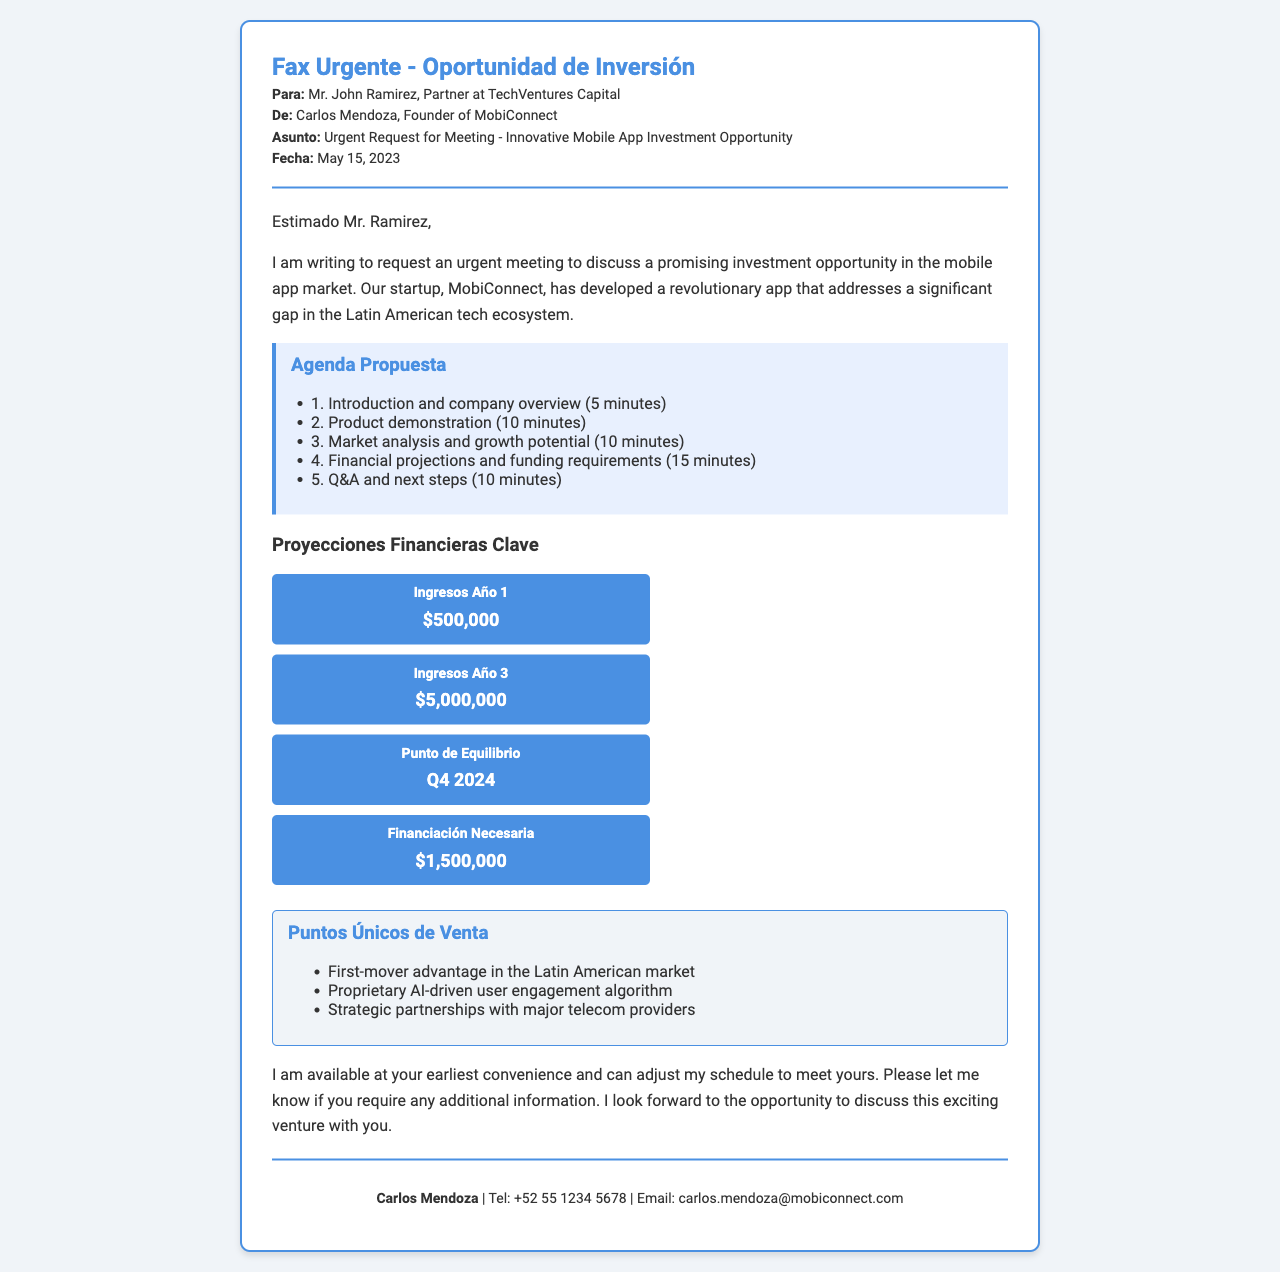¿Qué es MobiConnect? MobiConnect es la startup que ha desarrollado una aplicación móvil innovadora.
Answer: Startup ¿Quién es el destinatario del fax? El destinatario es Mr. John Ramirez, socio en TechVentures Capital.
Answer: Mr. John Ramirez ¿Cuál es la fecha del fax? La fecha del fax es el 15 de mayo de 2023.
Answer: May 15, 2023 ¿Cuánto financiamiento necesita MobiConnect? La financiación necesaria según el documento es de $1,500,000.
Answer: $1,500,000 ¿Cuáles son los ingresos proyectados para el Año 3? Los ingresos proyectados para el Año 3 son de $5,000,000.
Answer: $5,000,000 ¿Cuál es un punto único de venta mencionado? Un punto único de venta es la ventaja de ser el primer en el mercado latinoamericano.
Answer: First-mover advantage ¿Cuánto tiempo se dedicará a la demostración del producto en la reunión? Se dedicará 10 minutos a la demostración del producto.
Answer: 10 minutos ¿Cuándo se espera alcanzar el punto de equilibrio? El punto de equilibrio se espera alcanzar en el cuarto trimestre de 2024.
Answer: Q4 2024 ¿Cuál es el número de contacto de Carlos Mendoza? El número de contacto de Carlos Mendoza es +52 55 1234 5678.
Answer: +52 55 1234 5678 